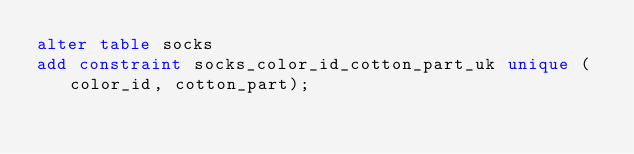<code> <loc_0><loc_0><loc_500><loc_500><_SQL_>alter table socks
add constraint socks_color_id_cotton_part_uk unique (color_id, cotton_part);</code> 